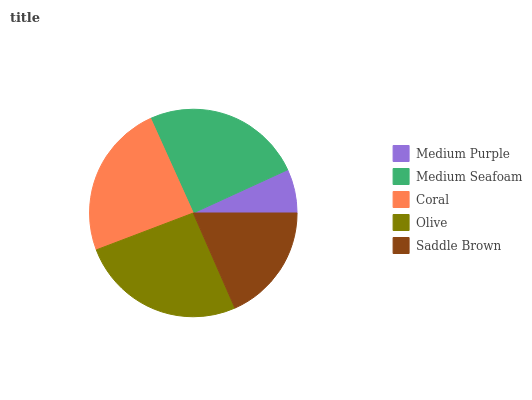Is Medium Purple the minimum?
Answer yes or no. Yes. Is Olive the maximum?
Answer yes or no. Yes. Is Medium Seafoam the minimum?
Answer yes or no. No. Is Medium Seafoam the maximum?
Answer yes or no. No. Is Medium Seafoam greater than Medium Purple?
Answer yes or no. Yes. Is Medium Purple less than Medium Seafoam?
Answer yes or no. Yes. Is Medium Purple greater than Medium Seafoam?
Answer yes or no. No. Is Medium Seafoam less than Medium Purple?
Answer yes or no. No. Is Coral the high median?
Answer yes or no. Yes. Is Coral the low median?
Answer yes or no. Yes. Is Olive the high median?
Answer yes or no. No. Is Saddle Brown the low median?
Answer yes or no. No. 